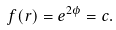Convert formula to latex. <formula><loc_0><loc_0><loc_500><loc_500>f ( r ) = e ^ { 2 \phi } = c .</formula> 